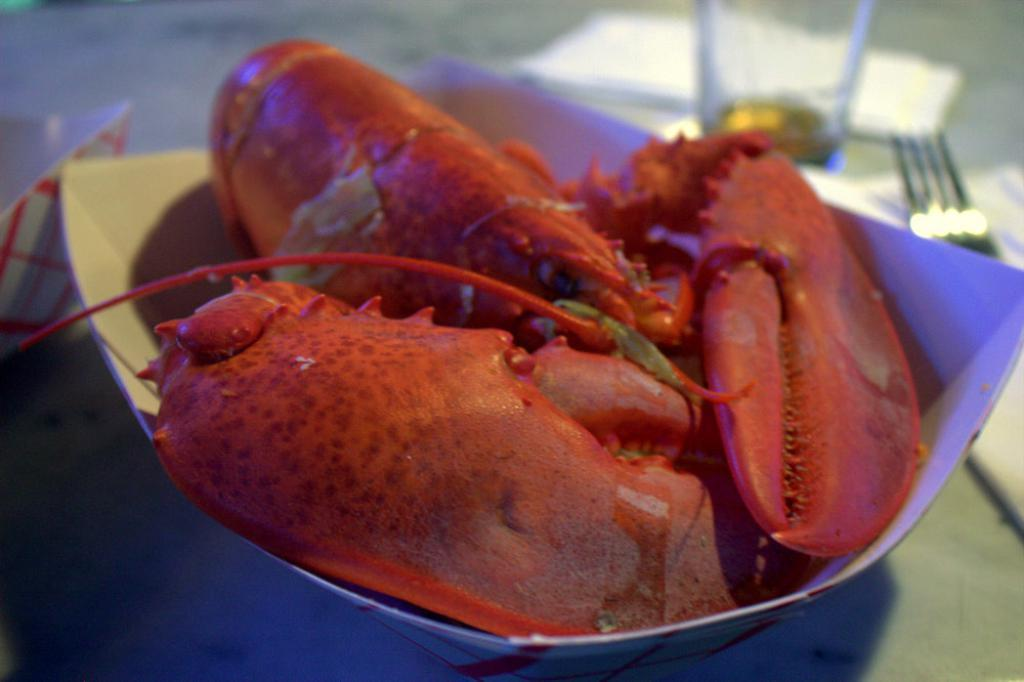What type of animal is in the image? There is a red color crab in the image. Where is the crab located? The crab is in a box. What is the box placed on? The box is on a table. Are there any other objects on the table? Yes, there are other objects on the table. Can you tell me how many cups are on the table in the image? There is no mention of cups in the image, so it is not possible to determine their presence or quantity. 